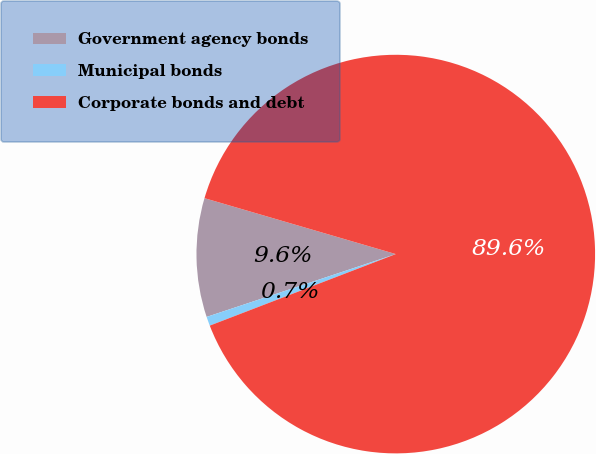<chart> <loc_0><loc_0><loc_500><loc_500><pie_chart><fcel>Government agency bonds<fcel>Municipal bonds<fcel>Corporate bonds and debt<nl><fcel>9.63%<fcel>0.74%<fcel>89.63%<nl></chart> 